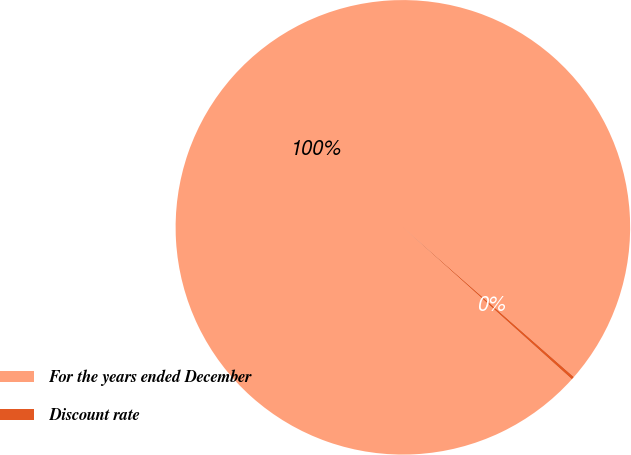<chart> <loc_0><loc_0><loc_500><loc_500><pie_chart><fcel>For the years ended December<fcel>Discount rate<nl><fcel>99.78%<fcel>0.22%<nl></chart> 